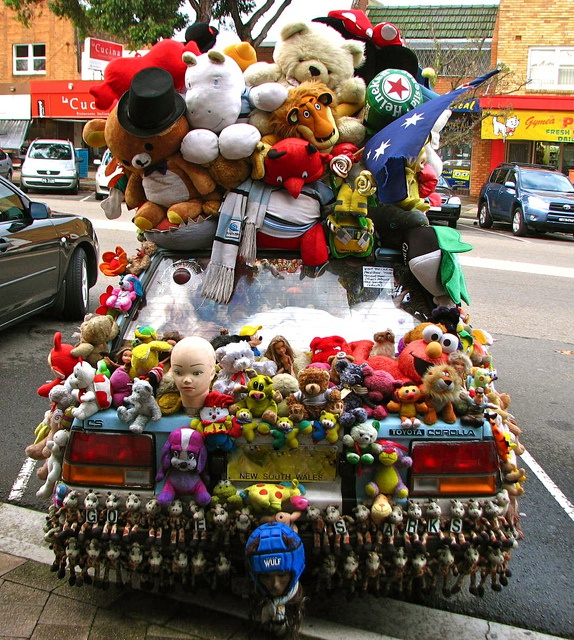Describe the objects in this image and their specific colors. I can see car in orange, black, white, maroon, and darkgray tones, teddy bear in orange, black, maroon, brown, and gray tones, car in orange, black, gray, and darkgray tones, teddy bear in orange, ivory, and tan tones, and car in orange, black, white, lightblue, and gray tones in this image. 